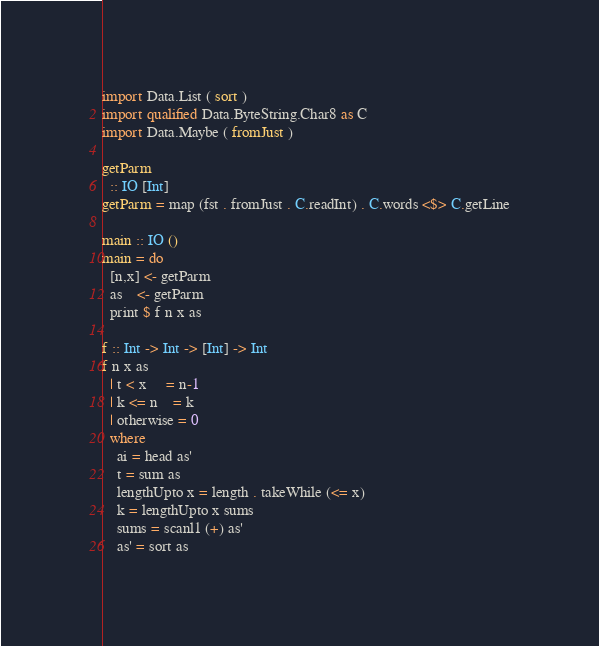Convert code to text. <code><loc_0><loc_0><loc_500><loc_500><_Haskell_>import Data.List ( sort )
import qualified Data.ByteString.Char8 as C
import Data.Maybe ( fromJust )

getParm
  :: IO [Int]
getParm = map (fst . fromJust . C.readInt) . C.words <$> C.getLine

main :: IO ()
main = do
  [n,x] <- getParm
  as    <- getParm
  print $ f n x as

f :: Int -> Int -> [Int] -> Int
f n x as
  | t < x     = n-1
  | k <= n    = k   
  | otherwise = 0
  where
    ai = head as'
    t = sum as
    lengthUpto x = length . takeWhile (<= x) 
    k = lengthUpto x sums
    sums = scanl1 (+) as'
    as' = sort as</code> 